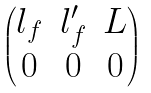<formula> <loc_0><loc_0><loc_500><loc_500>\begin{pmatrix} l _ { f } & l ^ { \prime } _ { f } & L \\ 0 & 0 & 0 \end{pmatrix}</formula> 